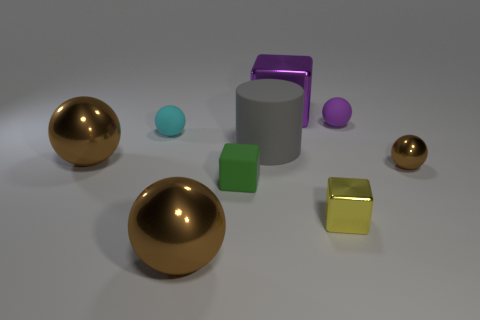How many balls are either metallic things or purple metal objects?
Ensure brevity in your answer.  3. There is a matte thing that is both behind the big matte cylinder and in front of the purple ball; what shape is it?
Provide a succinct answer. Sphere. Is the number of purple metallic blocks on the right side of the small metal cube the same as the number of tiny objects to the left of the big shiny block?
Keep it short and to the point. No. How many things are big purple metal blocks or small purple matte things?
Your answer should be compact. 2. The other rubber sphere that is the same size as the purple matte ball is what color?
Offer a very short reply. Cyan. What number of things are small balls in front of the small purple matte ball or cyan balls behind the green rubber object?
Your response must be concise. 2. Are there the same number of small green things on the right side of the yellow cube and small red matte blocks?
Provide a succinct answer. Yes. There is a shiny block that is in front of the small metal ball; is its size the same as the cube that is behind the big gray matte object?
Provide a succinct answer. No. How many other things are there of the same size as the green rubber block?
Provide a succinct answer. 4. Are there any small cyan spheres that are in front of the tiny brown object that is to the right of the rubber ball right of the big rubber object?
Your response must be concise. No. 